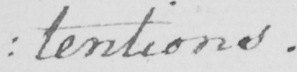Can you tell me what this handwritten text says? : tentions . 